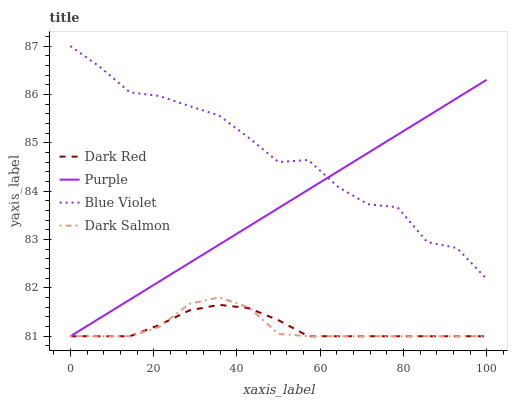Does Dark Salmon have the minimum area under the curve?
Answer yes or no. Yes. Does Blue Violet have the maximum area under the curve?
Answer yes or no. Yes. Does Dark Red have the minimum area under the curve?
Answer yes or no. No. Does Dark Red have the maximum area under the curve?
Answer yes or no. No. Is Purple the smoothest?
Answer yes or no. Yes. Is Blue Violet the roughest?
Answer yes or no. Yes. Is Dark Red the smoothest?
Answer yes or no. No. Is Dark Red the roughest?
Answer yes or no. No. Does Purple have the lowest value?
Answer yes or no. Yes. Does Blue Violet have the lowest value?
Answer yes or no. No. Does Blue Violet have the highest value?
Answer yes or no. Yes. Does Dark Salmon have the highest value?
Answer yes or no. No. Is Dark Salmon less than Blue Violet?
Answer yes or no. Yes. Is Blue Violet greater than Dark Red?
Answer yes or no. Yes. Does Purple intersect Dark Red?
Answer yes or no. Yes. Is Purple less than Dark Red?
Answer yes or no. No. Is Purple greater than Dark Red?
Answer yes or no. No. Does Dark Salmon intersect Blue Violet?
Answer yes or no. No. 